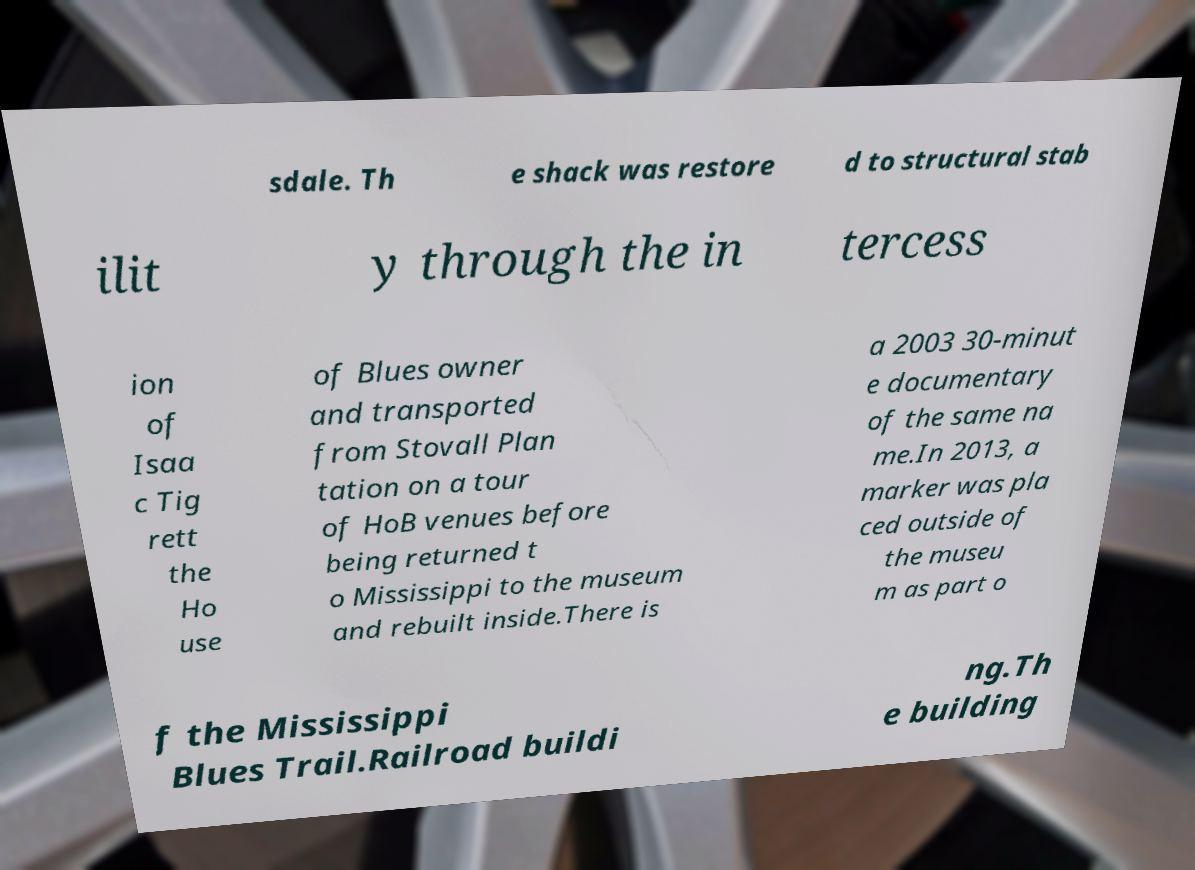For documentation purposes, I need the text within this image transcribed. Could you provide that? sdale. Th e shack was restore d to structural stab ilit y through the in tercess ion of Isaa c Tig rett the Ho use of Blues owner and transported from Stovall Plan tation on a tour of HoB venues before being returned t o Mississippi to the museum and rebuilt inside.There is a 2003 30-minut e documentary of the same na me.In 2013, a marker was pla ced outside of the museu m as part o f the Mississippi Blues Trail.Railroad buildi ng.Th e building 